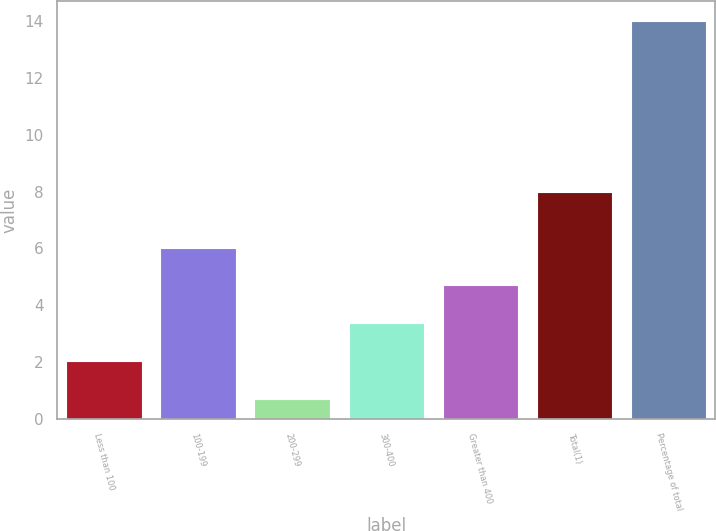Convert chart. <chart><loc_0><loc_0><loc_500><loc_500><bar_chart><fcel>Less than 100<fcel>100-199<fcel>200-299<fcel>300-400<fcel>Greater than 400<fcel>Total(1)<fcel>Percentage of total<nl><fcel>2.03<fcel>6.02<fcel>0.7<fcel>3.36<fcel>4.69<fcel>8<fcel>14<nl></chart> 